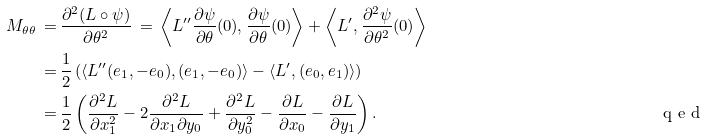<formula> <loc_0><loc_0><loc_500><loc_500>M _ { \theta \theta } \, = \, & \frac { \partial ^ { 2 } ( L \circ \psi ) } { \partial \theta ^ { 2 } } \, = \, \left \langle L ^ { \prime \prime } \frac { \partial \psi } { \partial \theta } ( 0 ) , \frac { \partial \psi } { \partial \theta } ( 0 ) \right \rangle + \left \langle L ^ { \prime } , \frac { \partial ^ { 2 } \psi } { \partial \theta ^ { 2 } } ( 0 ) \right \rangle \\ = \, & \frac { 1 } { 2 } \left ( \langle L ^ { \prime \prime } ( e _ { 1 } , - e _ { 0 } ) , ( e _ { 1 } , - e _ { 0 } ) \rangle - \langle L ^ { \prime } , ( e _ { 0 } , e _ { 1 } ) \rangle \right ) \\ = \, & \frac { 1 } { 2 } \left ( \frac { \partial ^ { 2 } L } { \partial x _ { 1 } ^ { 2 } } - 2 \frac { \partial ^ { 2 } L } { \partial x _ { 1 } \partial y _ { 0 } } + \frac { \partial ^ { 2 } L } { \partial y _ { 0 } ^ { 2 } } - \frac { \partial L } { \partial x _ { 0 } } - \frac { \partial L } { \partial y _ { 1 } } \right ) . \tag* { \ q e d }</formula> 